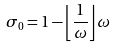Convert formula to latex. <formula><loc_0><loc_0><loc_500><loc_500>\sigma _ { 0 } = 1 - \left \lfloor \frac { 1 } { \omega } \right \rfloor \omega</formula> 